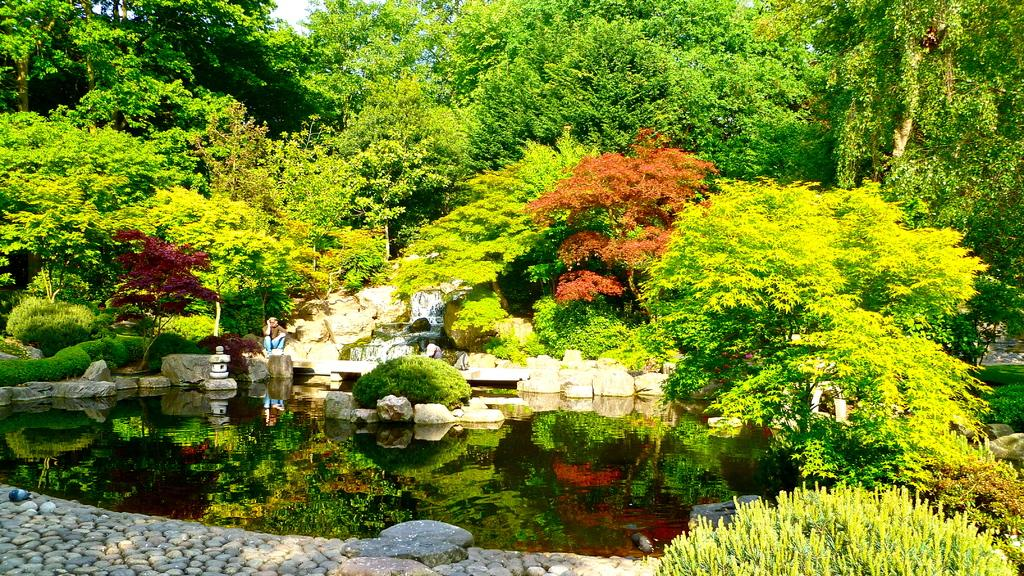What is the person in the image doing? The person is sitting on a rock. What is in front of the person? There is water in front of the person. What can be seen in the background of the image? There are trees in the background of the image. What type of poison is the person holding in the image? There is no poison present in the image; the person is simply sitting on a rock with water in front of them and trees in the background. 